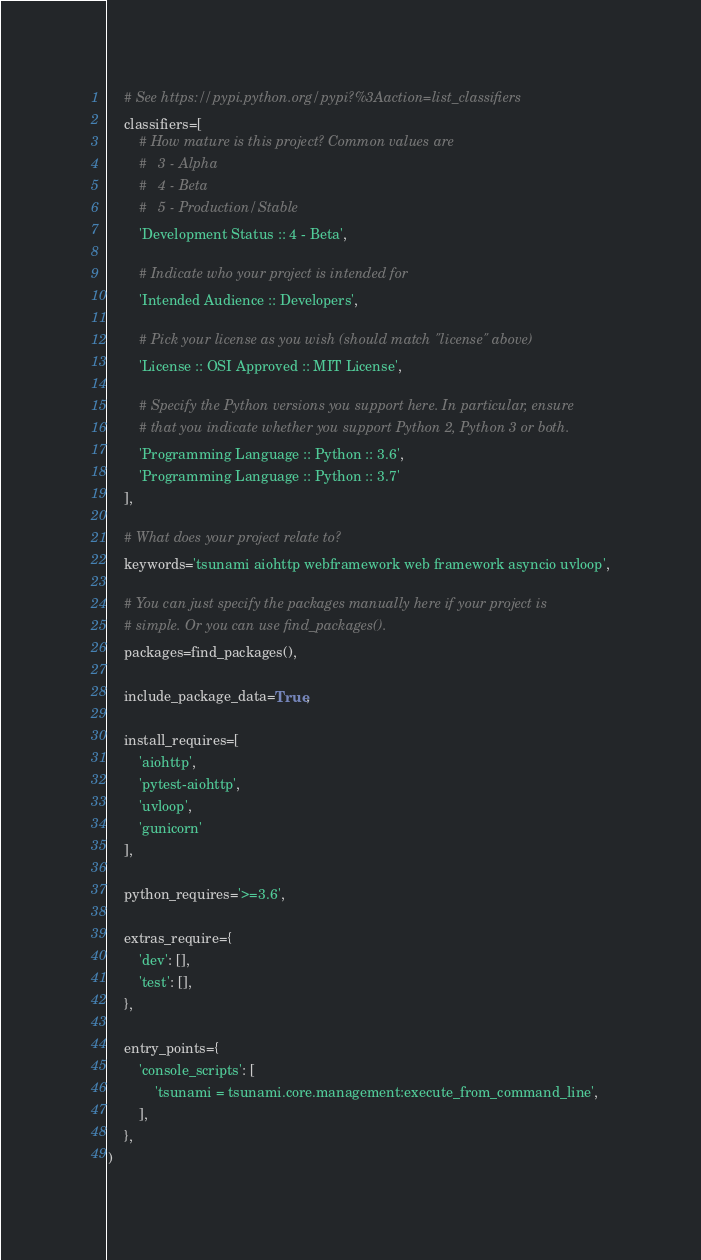Convert code to text. <code><loc_0><loc_0><loc_500><loc_500><_Python_>
    # See https://pypi.python.org/pypi?%3Aaction=list_classifiers
    classifiers=[
        # How mature is this project? Common values are
        #   3 - Alpha
        #   4 - Beta
        #   5 - Production/Stable
        'Development Status :: 4 - Beta',

        # Indicate who your project is intended for
        'Intended Audience :: Developers',

        # Pick your license as you wish (should match "license" above)
        'License :: OSI Approved :: MIT License',

        # Specify the Python versions you support here. In particular, ensure
        # that you indicate whether you support Python 2, Python 3 or both.
        'Programming Language :: Python :: 3.6',
        'Programming Language :: Python :: 3.7'
    ],

    # What does your project relate to?
    keywords='tsunami aiohttp webframework web framework asyncio uvloop',

    # You can just specify the packages manually here if your project is
    # simple. Or you can use find_packages().
    packages=find_packages(),

    include_package_data=True,

    install_requires=[
        'aiohttp',
        'pytest-aiohttp',
        'uvloop',
        'gunicorn'
    ],

    python_requires='>=3.6',

    extras_require={
        'dev': [],
        'test': [],
    },

    entry_points={
        'console_scripts': [
            'tsunami = tsunami.core.management:execute_from_command_line',
        ],
    },
)</code> 